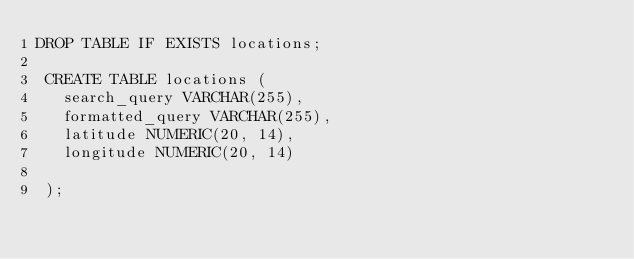Convert code to text. <code><loc_0><loc_0><loc_500><loc_500><_SQL_>DROP TABLE IF EXISTS locations;
 
 CREATE TABLE locations (
   search_query VARCHAR(255),
   formatted_query VARCHAR(255),
   latitude NUMERIC(20, 14),
   longitude NUMERIC(20, 14)
 
 );</code> 